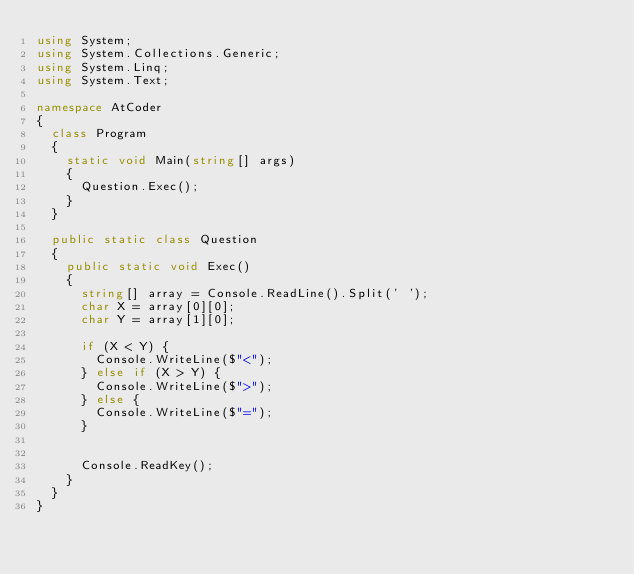Convert code to text. <code><loc_0><loc_0><loc_500><loc_500><_C#_>using System;
using System.Collections.Generic;
using System.Linq;
using System.Text;

namespace AtCoder
{
	class Program
	{
		static void Main(string[] args)
		{
			Question.Exec();
		}
	}

	public static class Question
	{
		public static void Exec()
		{
			string[] array = Console.ReadLine().Split(' ');
			char X = array[0][0];
			char Y = array[1][0];

			if (X < Y) {
				Console.WriteLine($"<");
			} else if (X > Y) {
				Console.WriteLine($">");
			} else {
				Console.WriteLine($"=");
			}
			

			Console.ReadKey();
		}
	}
}</code> 